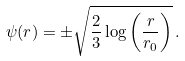Convert formula to latex. <formula><loc_0><loc_0><loc_500><loc_500>\psi ( r ) = \pm \sqrt { \frac { 2 } { 3 } \log \left ( \frac { r } { r _ { 0 } } \right ) } \, .</formula> 